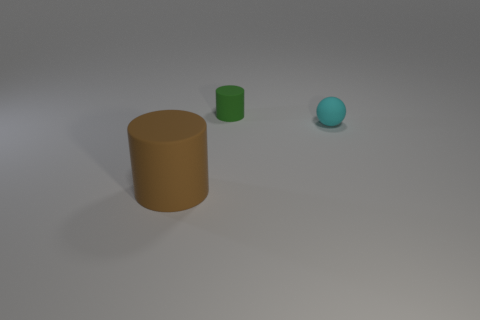Is the number of matte objects in front of the cyan object less than the number of large matte cylinders that are behind the brown thing?
Your response must be concise. No. What number of cyan rubber objects have the same shape as the tiny green object?
Make the answer very short. 0. There is a brown cylinder that is made of the same material as the small cyan ball; what size is it?
Offer a terse response. Large. What color is the rubber cylinder behind the matte object in front of the tiny ball?
Keep it short and to the point. Green. Is the shape of the large thing the same as the object that is behind the cyan rubber sphere?
Offer a very short reply. Yes. How many other brown objects are the same size as the brown thing?
Give a very brief answer. 0. There is a small green object that is the same shape as the large rubber object; what material is it?
Provide a succinct answer. Rubber. There is a tiny matte thing behind the cyan matte object; does it have the same color as the tiny matte object in front of the green rubber object?
Give a very brief answer. No. What is the shape of the thing behind the cyan matte object?
Your answer should be very brief. Cylinder. What is the color of the small rubber cylinder?
Provide a succinct answer. Green. 